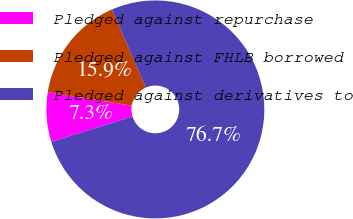Convert chart. <chart><loc_0><loc_0><loc_500><loc_500><pie_chart><fcel>Pledged against repurchase<fcel>Pledged against FHLB borrowed<fcel>Pledged against derivatives to<nl><fcel>7.35%<fcel>15.92%<fcel>76.74%<nl></chart> 